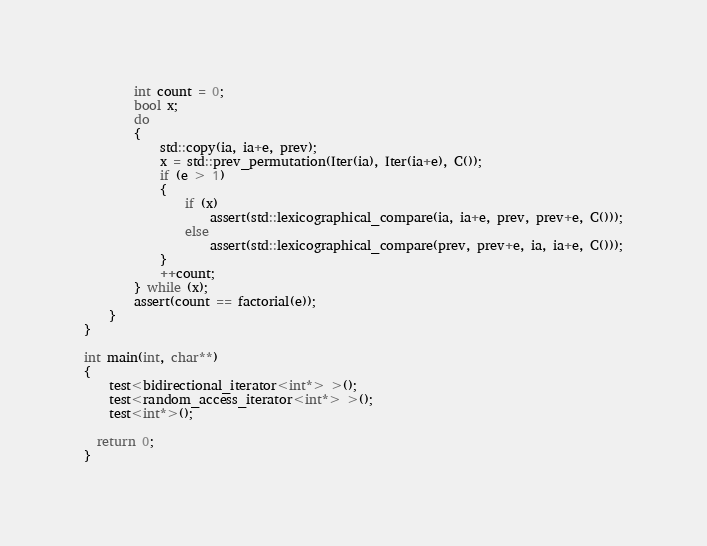Convert code to text. <code><loc_0><loc_0><loc_500><loc_500><_C++_>        int count = 0;
        bool x;
        do
        {
            std::copy(ia, ia+e, prev);
            x = std::prev_permutation(Iter(ia), Iter(ia+e), C());
            if (e > 1)
            {
                if (x)
                    assert(std::lexicographical_compare(ia, ia+e, prev, prev+e, C()));
                else
                    assert(std::lexicographical_compare(prev, prev+e, ia, ia+e, C()));
            }
            ++count;
        } while (x);
        assert(count == factorial(e));
    }
}

int main(int, char**)
{
    test<bidirectional_iterator<int*> >();
    test<random_access_iterator<int*> >();
    test<int*>();

  return 0;
}
</code> 